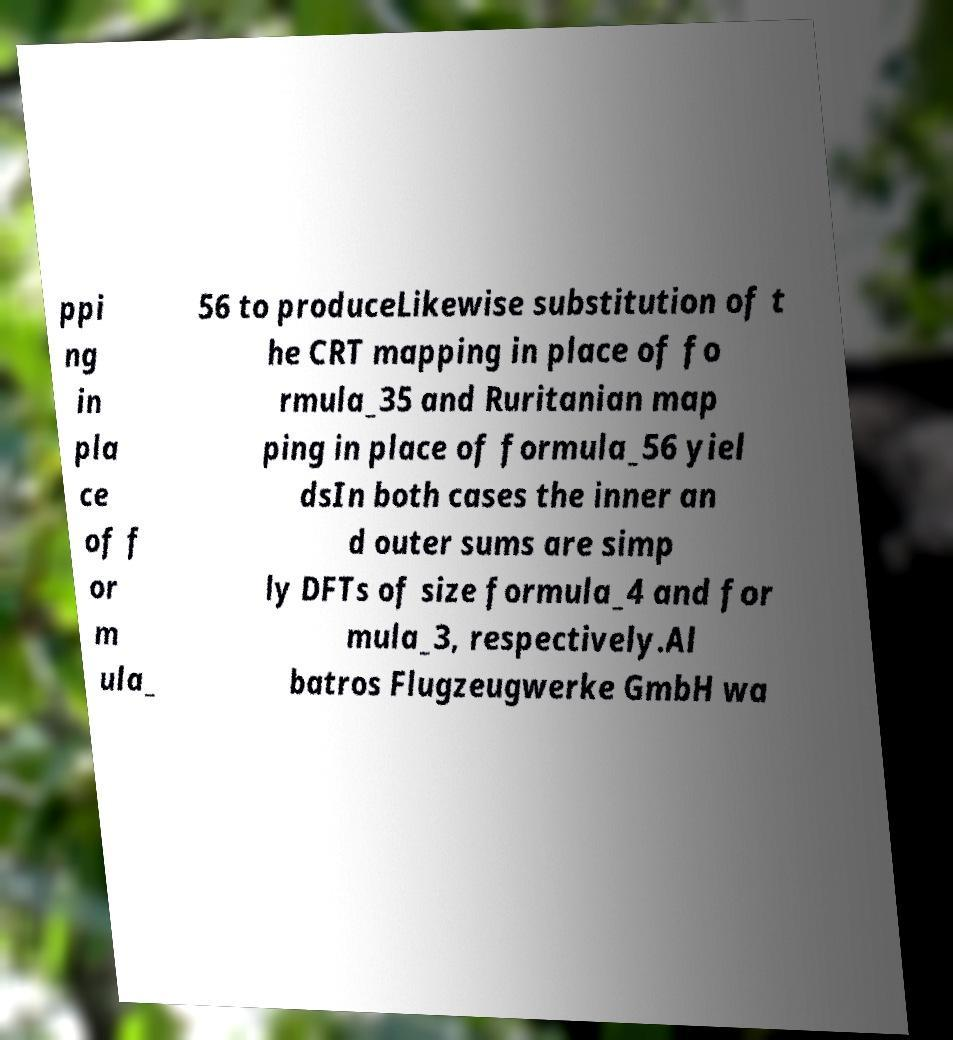For documentation purposes, I need the text within this image transcribed. Could you provide that? ppi ng in pla ce of f or m ula_ 56 to produceLikewise substitution of t he CRT mapping in place of fo rmula_35 and Ruritanian map ping in place of formula_56 yiel dsIn both cases the inner an d outer sums are simp ly DFTs of size formula_4 and for mula_3, respectively.Al batros Flugzeugwerke GmbH wa 